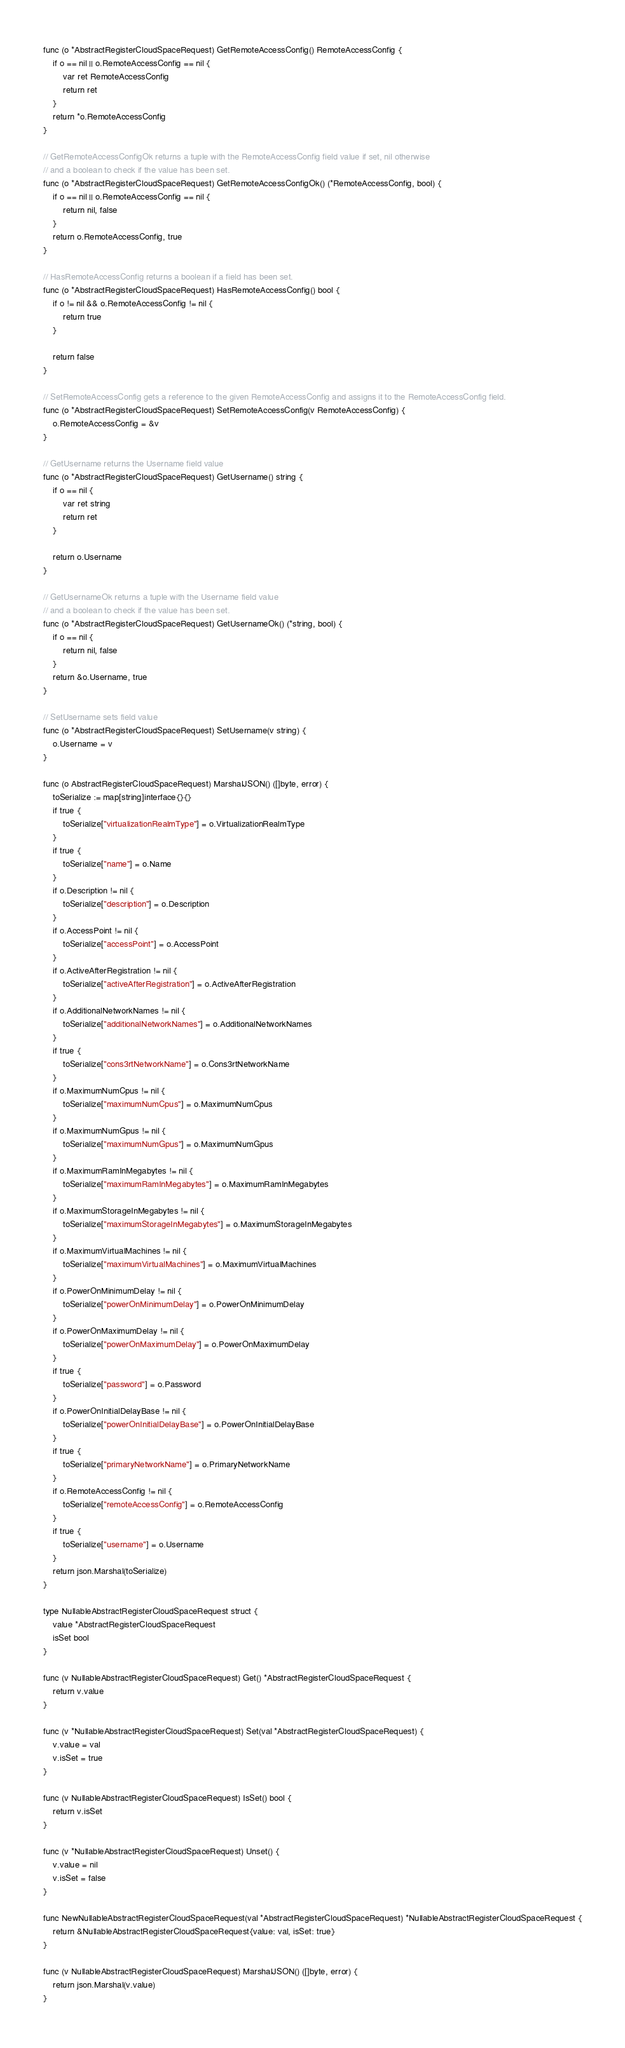<code> <loc_0><loc_0><loc_500><loc_500><_Go_>func (o *AbstractRegisterCloudSpaceRequest) GetRemoteAccessConfig() RemoteAccessConfig {
	if o == nil || o.RemoteAccessConfig == nil {
		var ret RemoteAccessConfig
		return ret
	}
	return *o.RemoteAccessConfig
}

// GetRemoteAccessConfigOk returns a tuple with the RemoteAccessConfig field value if set, nil otherwise
// and a boolean to check if the value has been set.
func (o *AbstractRegisterCloudSpaceRequest) GetRemoteAccessConfigOk() (*RemoteAccessConfig, bool) {
	if o == nil || o.RemoteAccessConfig == nil {
		return nil, false
	}
	return o.RemoteAccessConfig, true
}

// HasRemoteAccessConfig returns a boolean if a field has been set.
func (o *AbstractRegisterCloudSpaceRequest) HasRemoteAccessConfig() bool {
	if o != nil && o.RemoteAccessConfig != nil {
		return true
	}

	return false
}

// SetRemoteAccessConfig gets a reference to the given RemoteAccessConfig and assigns it to the RemoteAccessConfig field.
func (o *AbstractRegisterCloudSpaceRequest) SetRemoteAccessConfig(v RemoteAccessConfig) {
	o.RemoteAccessConfig = &v
}

// GetUsername returns the Username field value
func (o *AbstractRegisterCloudSpaceRequest) GetUsername() string {
	if o == nil {
		var ret string
		return ret
	}

	return o.Username
}

// GetUsernameOk returns a tuple with the Username field value
// and a boolean to check if the value has been set.
func (o *AbstractRegisterCloudSpaceRequest) GetUsernameOk() (*string, bool) {
	if o == nil {
		return nil, false
	}
	return &o.Username, true
}

// SetUsername sets field value
func (o *AbstractRegisterCloudSpaceRequest) SetUsername(v string) {
	o.Username = v
}

func (o AbstractRegisterCloudSpaceRequest) MarshalJSON() ([]byte, error) {
	toSerialize := map[string]interface{}{}
	if true {
		toSerialize["virtualizationRealmType"] = o.VirtualizationRealmType
	}
	if true {
		toSerialize["name"] = o.Name
	}
	if o.Description != nil {
		toSerialize["description"] = o.Description
	}
	if o.AccessPoint != nil {
		toSerialize["accessPoint"] = o.AccessPoint
	}
	if o.ActiveAfterRegistration != nil {
		toSerialize["activeAfterRegistration"] = o.ActiveAfterRegistration
	}
	if o.AdditionalNetworkNames != nil {
		toSerialize["additionalNetworkNames"] = o.AdditionalNetworkNames
	}
	if true {
		toSerialize["cons3rtNetworkName"] = o.Cons3rtNetworkName
	}
	if o.MaximumNumCpus != nil {
		toSerialize["maximumNumCpus"] = o.MaximumNumCpus
	}
	if o.MaximumNumGpus != nil {
		toSerialize["maximumNumGpus"] = o.MaximumNumGpus
	}
	if o.MaximumRamInMegabytes != nil {
		toSerialize["maximumRamInMegabytes"] = o.MaximumRamInMegabytes
	}
	if o.MaximumStorageInMegabytes != nil {
		toSerialize["maximumStorageInMegabytes"] = o.MaximumStorageInMegabytes
	}
	if o.MaximumVirtualMachines != nil {
		toSerialize["maximumVirtualMachines"] = o.MaximumVirtualMachines
	}
	if o.PowerOnMinimumDelay != nil {
		toSerialize["powerOnMinimumDelay"] = o.PowerOnMinimumDelay
	}
	if o.PowerOnMaximumDelay != nil {
		toSerialize["powerOnMaximumDelay"] = o.PowerOnMaximumDelay
	}
	if true {
		toSerialize["password"] = o.Password
	}
	if o.PowerOnInitialDelayBase != nil {
		toSerialize["powerOnInitialDelayBase"] = o.PowerOnInitialDelayBase
	}
	if true {
		toSerialize["primaryNetworkName"] = o.PrimaryNetworkName
	}
	if o.RemoteAccessConfig != nil {
		toSerialize["remoteAccessConfig"] = o.RemoteAccessConfig
	}
	if true {
		toSerialize["username"] = o.Username
	}
	return json.Marshal(toSerialize)
}

type NullableAbstractRegisterCloudSpaceRequest struct {
	value *AbstractRegisterCloudSpaceRequest
	isSet bool
}

func (v NullableAbstractRegisterCloudSpaceRequest) Get() *AbstractRegisterCloudSpaceRequest {
	return v.value
}

func (v *NullableAbstractRegisterCloudSpaceRequest) Set(val *AbstractRegisterCloudSpaceRequest) {
	v.value = val
	v.isSet = true
}

func (v NullableAbstractRegisterCloudSpaceRequest) IsSet() bool {
	return v.isSet
}

func (v *NullableAbstractRegisterCloudSpaceRequest) Unset() {
	v.value = nil
	v.isSet = false
}

func NewNullableAbstractRegisterCloudSpaceRequest(val *AbstractRegisterCloudSpaceRequest) *NullableAbstractRegisterCloudSpaceRequest {
	return &NullableAbstractRegisterCloudSpaceRequest{value: val, isSet: true}
}

func (v NullableAbstractRegisterCloudSpaceRequest) MarshalJSON() ([]byte, error) {
	return json.Marshal(v.value)
}
</code> 